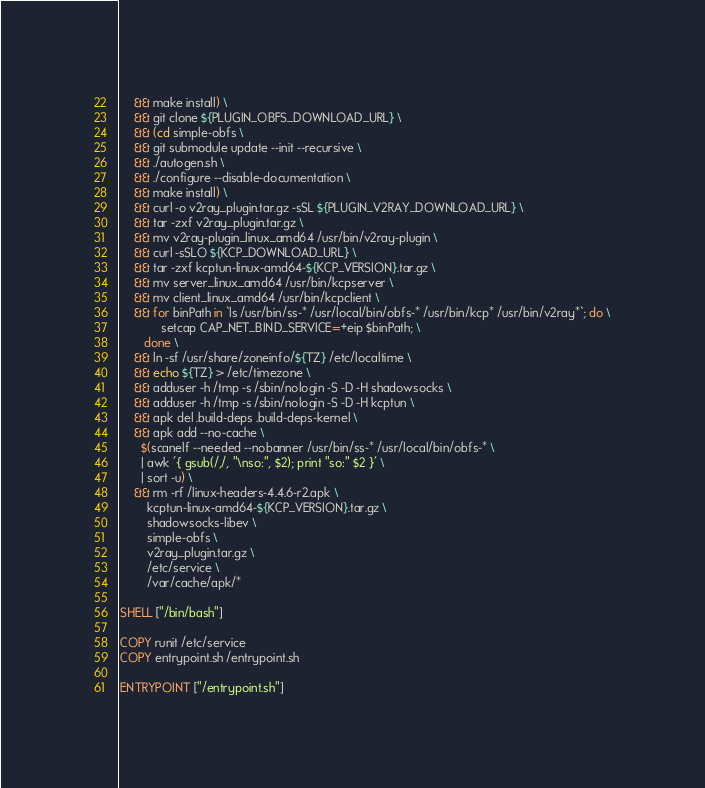Convert code to text. <code><loc_0><loc_0><loc_500><loc_500><_Dockerfile_>    && make install) \
    && git clone ${PLUGIN_OBFS_DOWNLOAD_URL} \
    && (cd simple-obfs \
    && git submodule update --init --recursive \
    && ./autogen.sh \
    && ./configure --disable-documentation \
    && make install) \
    && curl -o v2ray_plugin.tar.gz -sSL ${PLUGIN_V2RAY_DOWNLOAD_URL} \
    && tar -zxf v2ray_plugin.tar.gz \
    && mv v2ray-plugin_linux_amd64 /usr/bin/v2ray-plugin \
    && curl -sSLO ${KCP_DOWNLOAD_URL} \
    && tar -zxf kcptun-linux-amd64-${KCP_VERSION}.tar.gz \
    && mv server_linux_amd64 /usr/bin/kcpserver \
    && mv client_linux_amd64 /usr/bin/kcpclient \
    && for binPath in `ls /usr/bin/ss-* /usr/local/bin/obfs-* /usr/bin/kcp* /usr/bin/v2ray*`; do \
            setcap CAP_NET_BIND_SERVICE=+eip $binPath; \
       done \
    && ln -sf /usr/share/zoneinfo/${TZ} /etc/localtime \
    && echo ${TZ} > /etc/timezone \
    && adduser -h /tmp -s /sbin/nologin -S -D -H shadowsocks \
    && adduser -h /tmp -s /sbin/nologin -S -D -H kcptun \
    && apk del .build-deps .build-deps-kernel \
    && apk add --no-cache \
      $(scanelf --needed --nobanner /usr/bin/ss-* /usr/local/bin/obfs-* \
      | awk '{ gsub(/,/, "\nso:", $2); print "so:" $2 }' \
      | sort -u) \
    && rm -rf /linux-headers-4.4.6-r2.apk \
        kcptun-linux-amd64-${KCP_VERSION}.tar.gz \
        shadowsocks-libev \
        simple-obfs \
        v2ray_plugin.tar.gz \
        /etc/service \
        /var/cache/apk/*

SHELL ["/bin/bash"]

COPY runit /etc/service
COPY entrypoint.sh /entrypoint.sh

ENTRYPOINT ["/entrypoint.sh"]
</code> 